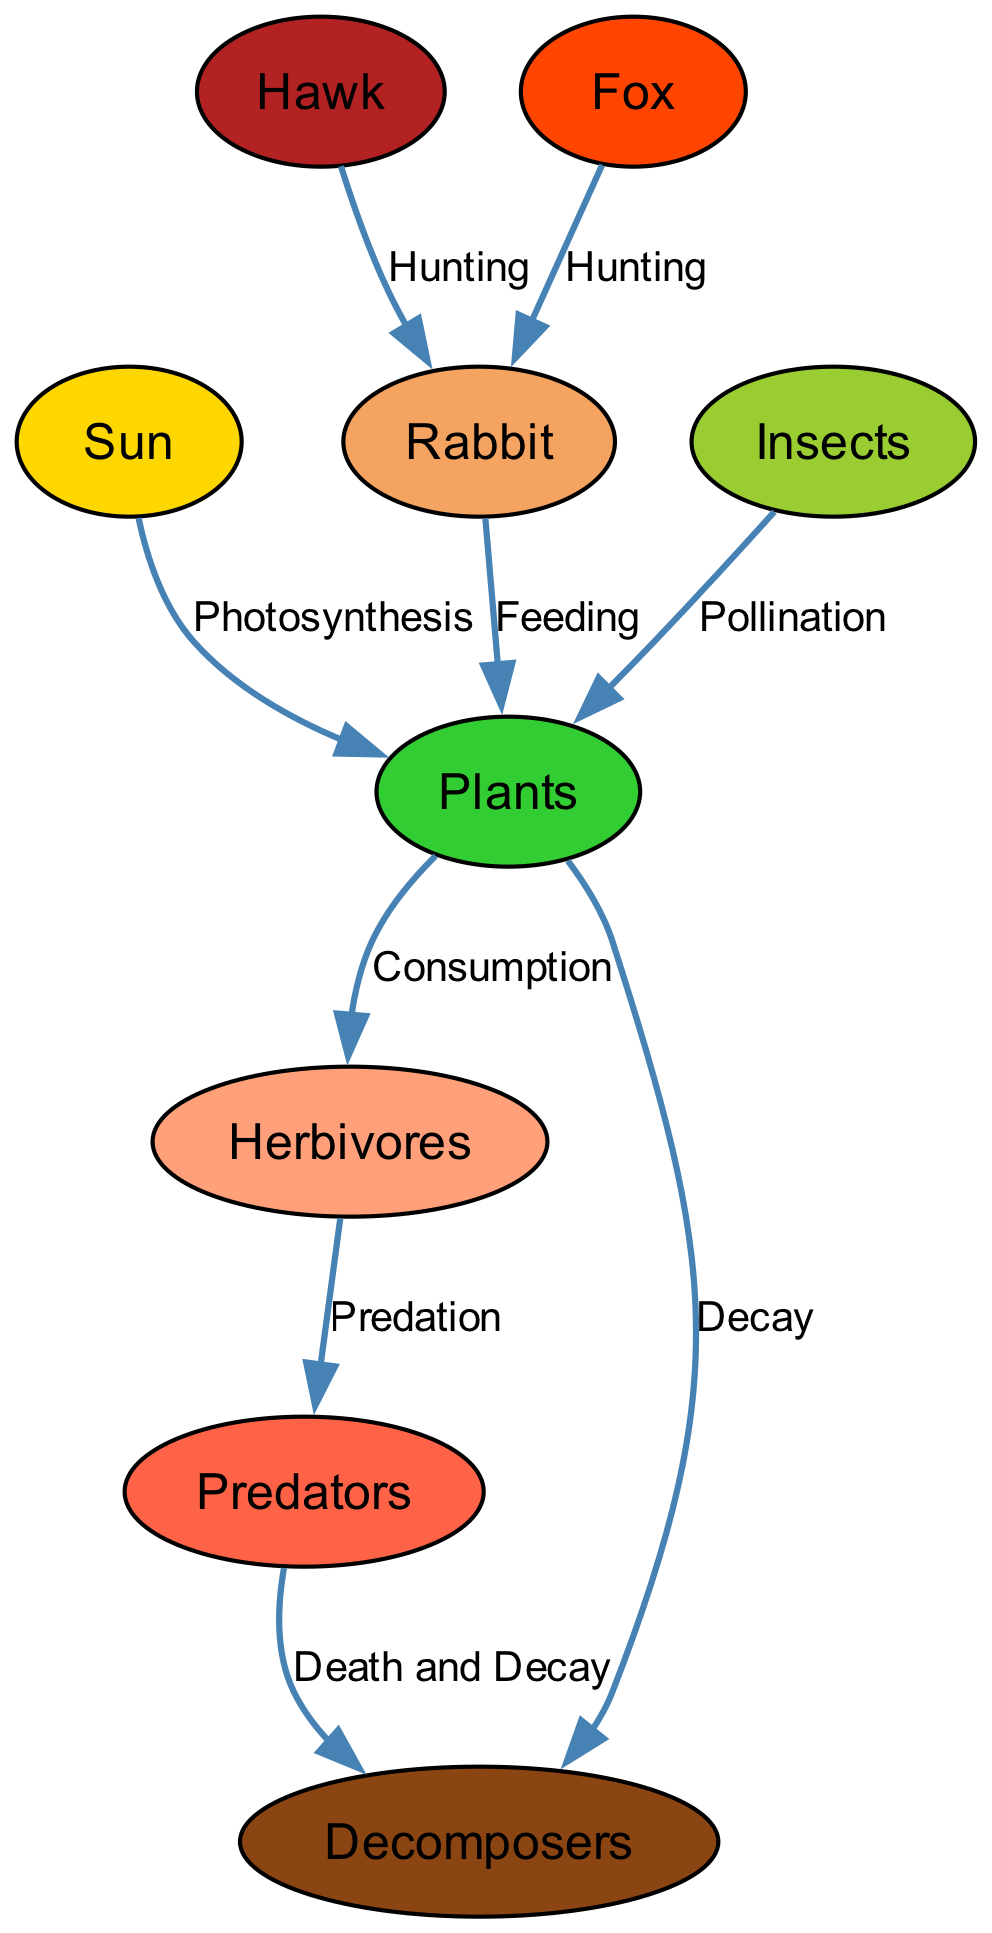What is the primary source of energy in this food web? The diagram shows that the Sun is the primary source of energy, as indicated by the edge connecting the Sun to the Plants with the label "Photosynthesis."
Answer: Sun How many herbivores are depicted in the diagram? By reviewing the nodes in the diagram, I find that "Herbivores" is presented as a collective category which includes specific species, like Rabbit. Hence, there is one node labeled as "Herbivores."
Answer: 1 What is the relationship between plants and herbivores? The edge connecting "Plants" to "Herbivores" is labeled "Consumption," indicating that herbivores consume plants for nourishment.
Answer: Consumption Which species are predators according to the diagram? The nodes classified under predators in the diagram include "Hawk" and "Fox," with edges showing their predation on "Rabbit."
Answer: Hawk, Fox How do decomposers relate to the overall ecosystem depicted in the diagram? The diagram illustrates the role of decomposers through edges linking them to both predators (after death) and plants (upon decay), highlighting their role in nutrient cycling.
Answer: Nutrient cycling What type of interaction occurs between insects and plants? The edge from "Insects" to "Plants" is labeled "Pollination," indicating a mutual benefit where insects aid in the reproduction of plants while feeding.
Answer: Pollination How many total nodes are present in the diagram? By counting the distinct nodes labeled in the diagram, including Sun, Plants, Herbivores, Predators, Decomposers, Hawk, Rabbit, Fox, and Insects, I determine that there are nine nodes.
Answer: 9 Which species contributes to the predatory relationship by consuming rabbits? The diagram shows that both the "Hawk" and the "Fox" have edges leading to "Rabbit," indicating they both prey on this herbivore.
Answer: Hawk, Fox What process do herbivores perform that contributes back to plants in the ecosystem? The edge labeled "Feeding" from "Rabbit" to "Plants" illustrates that herbivores, like rabbits, contribute by consuming plants, thus having a direct relationship in the food web.
Answer: Feeding 